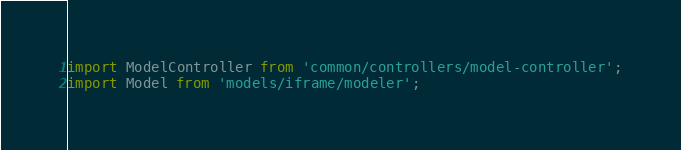Convert code to text. <code><loc_0><loc_0><loc_500><loc_500><_JavaScript_>
import ModelController from 'common/controllers/model-controller';
import Model from 'models/iframe/modeler';</code> 